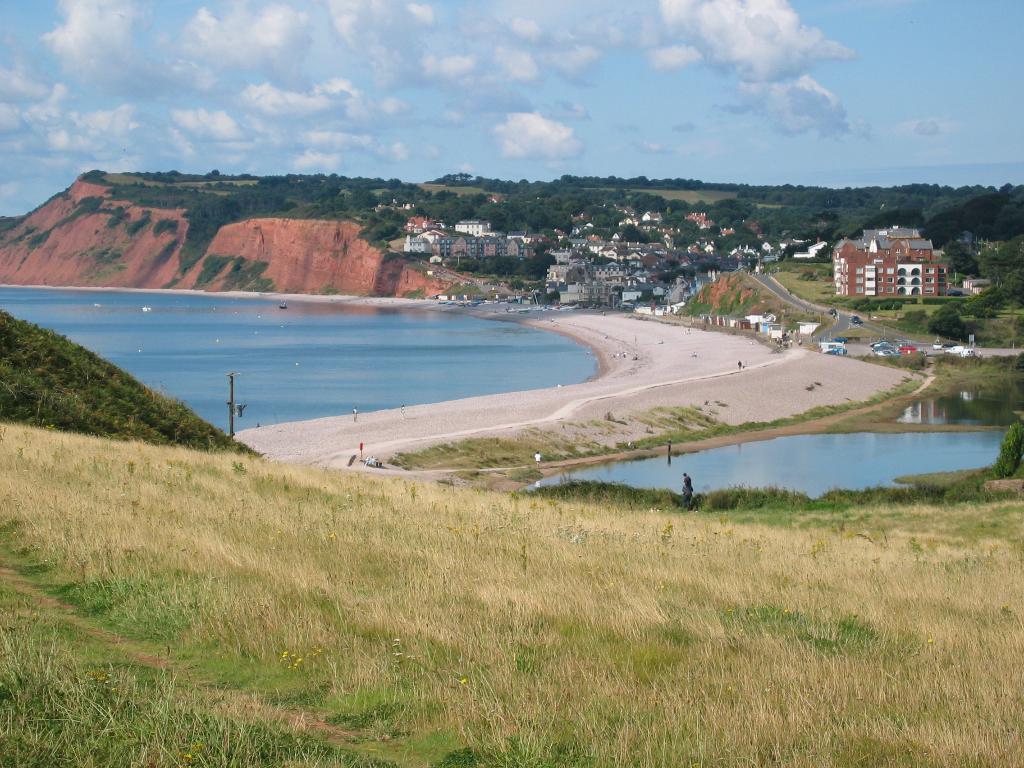How would you summarize this image in a sentence or two? This is an outside view. At the bottom, I can see the grass on the ground. In the middle of the image there is a beach and also there are many buildings. On the right side there are few vehicles on a road. On the left side there is a hill. In the background there are many trees. At the top of the image I can see the sky and clouds. 